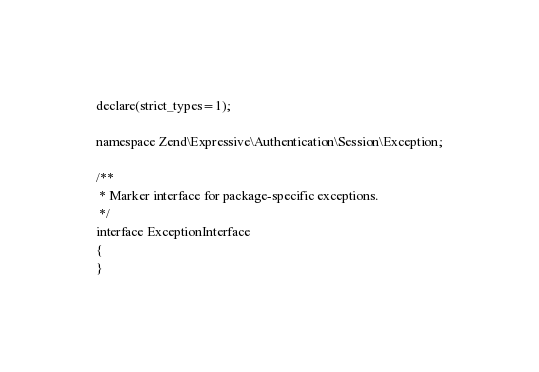Convert code to text. <code><loc_0><loc_0><loc_500><loc_500><_PHP_>
declare(strict_types=1);

namespace Zend\Expressive\Authentication\Session\Exception;

/**
 * Marker interface for package-specific exceptions.
 */
interface ExceptionInterface
{
}
</code> 